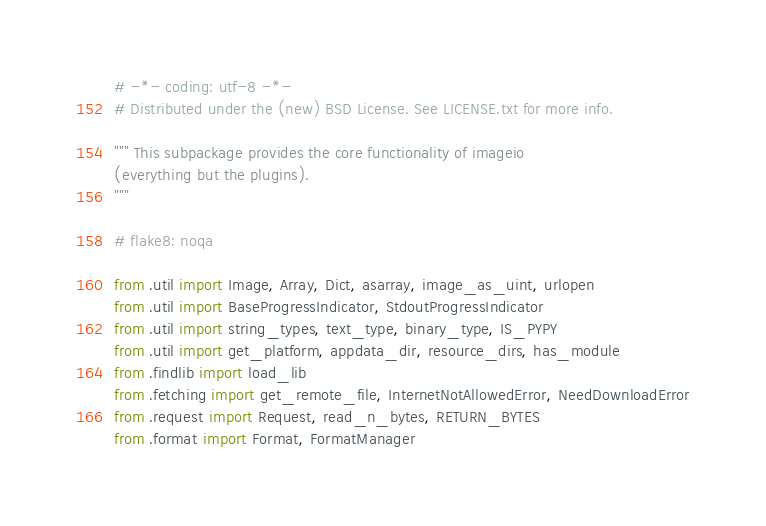<code> <loc_0><loc_0><loc_500><loc_500><_Python_># -*- coding: utf-8 -*-
# Distributed under the (new) BSD License. See LICENSE.txt for more info.

""" This subpackage provides the core functionality of imageio
(everything but the plugins).
"""

# flake8: noqa

from .util import Image, Array, Dict, asarray, image_as_uint, urlopen
from .util import BaseProgressIndicator, StdoutProgressIndicator
from .util import string_types, text_type, binary_type, IS_PYPY
from .util import get_platform, appdata_dir, resource_dirs, has_module
from .findlib import load_lib
from .fetching import get_remote_file, InternetNotAllowedError, NeedDownloadError
from .request import Request, read_n_bytes, RETURN_BYTES
from .format import Format, FormatManager
</code> 